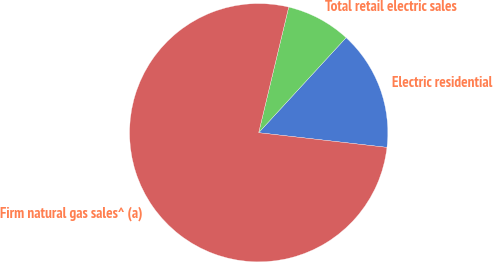Convert chart to OTSL. <chart><loc_0><loc_0><loc_500><loc_500><pie_chart><fcel>Electric residential<fcel>Total retail electric sales<fcel>Firm natural gas sales^ (a)<nl><fcel>14.98%<fcel>8.1%<fcel>76.92%<nl></chart> 